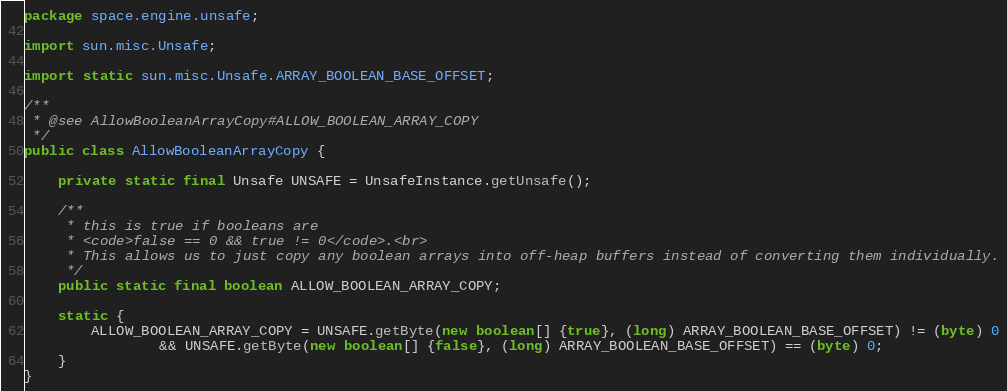Convert code to text. <code><loc_0><loc_0><loc_500><loc_500><_Java_>package space.engine.unsafe;

import sun.misc.Unsafe;

import static sun.misc.Unsafe.ARRAY_BOOLEAN_BASE_OFFSET;

/**
 * @see AllowBooleanArrayCopy#ALLOW_BOOLEAN_ARRAY_COPY
 */
public class AllowBooleanArrayCopy {
	
	private static final Unsafe UNSAFE = UnsafeInstance.getUnsafe();
	
	/**
	 * this is true if booleans are
	 * <code>false == 0 && true != 0</code>.<br>
	 * This allows us to just copy any boolean arrays into off-heap buffers instead of converting them individually.
	 */
	public static final boolean ALLOW_BOOLEAN_ARRAY_COPY;
	
	static {
		ALLOW_BOOLEAN_ARRAY_COPY = UNSAFE.getByte(new boolean[] {true}, (long) ARRAY_BOOLEAN_BASE_OFFSET) != (byte) 0
				&& UNSAFE.getByte(new boolean[] {false}, (long) ARRAY_BOOLEAN_BASE_OFFSET) == (byte) 0;
	}
}
</code> 